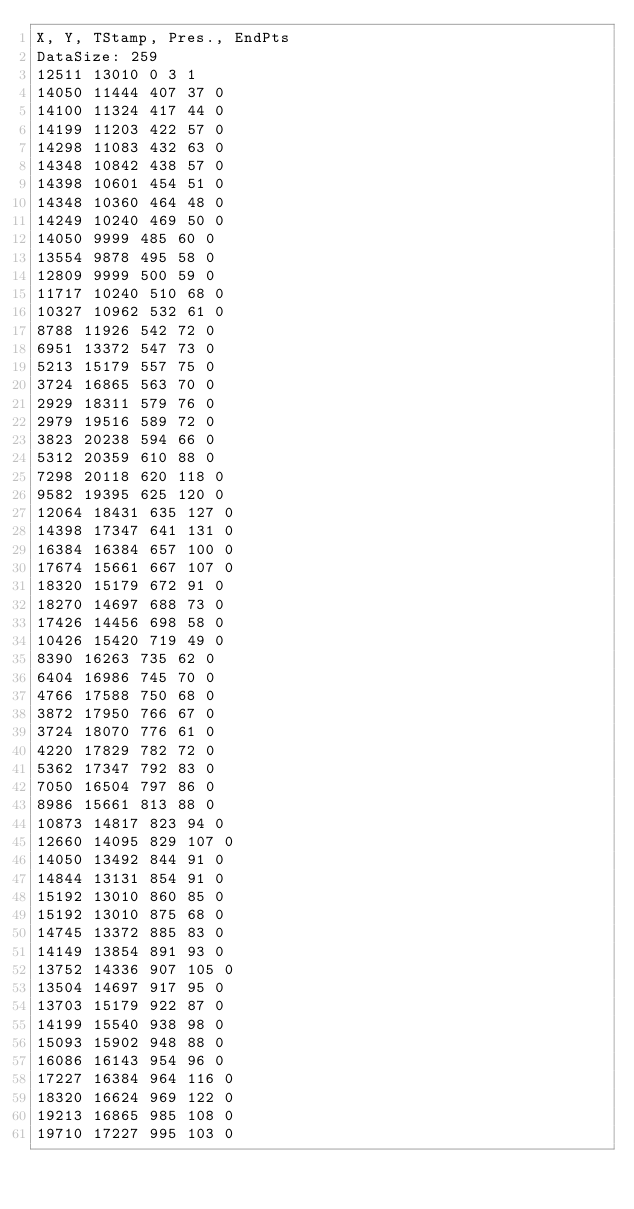<code> <loc_0><loc_0><loc_500><loc_500><_SML_>X, Y, TStamp, Pres., EndPts
DataSize: 259
12511 13010 0 3 1
14050 11444 407 37 0
14100 11324 417 44 0
14199 11203 422 57 0
14298 11083 432 63 0
14348 10842 438 57 0
14398 10601 454 51 0
14348 10360 464 48 0
14249 10240 469 50 0
14050 9999 485 60 0
13554 9878 495 58 0
12809 9999 500 59 0
11717 10240 510 68 0
10327 10962 532 61 0
8788 11926 542 72 0
6951 13372 547 73 0
5213 15179 557 75 0
3724 16865 563 70 0
2929 18311 579 76 0
2979 19516 589 72 0
3823 20238 594 66 0
5312 20359 610 88 0
7298 20118 620 118 0
9582 19395 625 120 0
12064 18431 635 127 0
14398 17347 641 131 0
16384 16384 657 100 0
17674 15661 667 107 0
18320 15179 672 91 0
18270 14697 688 73 0
17426 14456 698 58 0
10426 15420 719 49 0
8390 16263 735 62 0
6404 16986 745 70 0
4766 17588 750 68 0
3872 17950 766 67 0
3724 18070 776 61 0
4220 17829 782 72 0
5362 17347 792 83 0
7050 16504 797 86 0
8986 15661 813 88 0
10873 14817 823 94 0
12660 14095 829 107 0
14050 13492 844 91 0
14844 13131 854 91 0
15192 13010 860 85 0
15192 13010 875 68 0
14745 13372 885 83 0
14149 13854 891 93 0
13752 14336 907 105 0
13504 14697 917 95 0
13703 15179 922 87 0
14199 15540 938 98 0
15093 15902 948 88 0
16086 16143 954 96 0
17227 16384 964 116 0
18320 16624 969 122 0
19213 16865 985 108 0
19710 17227 995 103 0</code> 